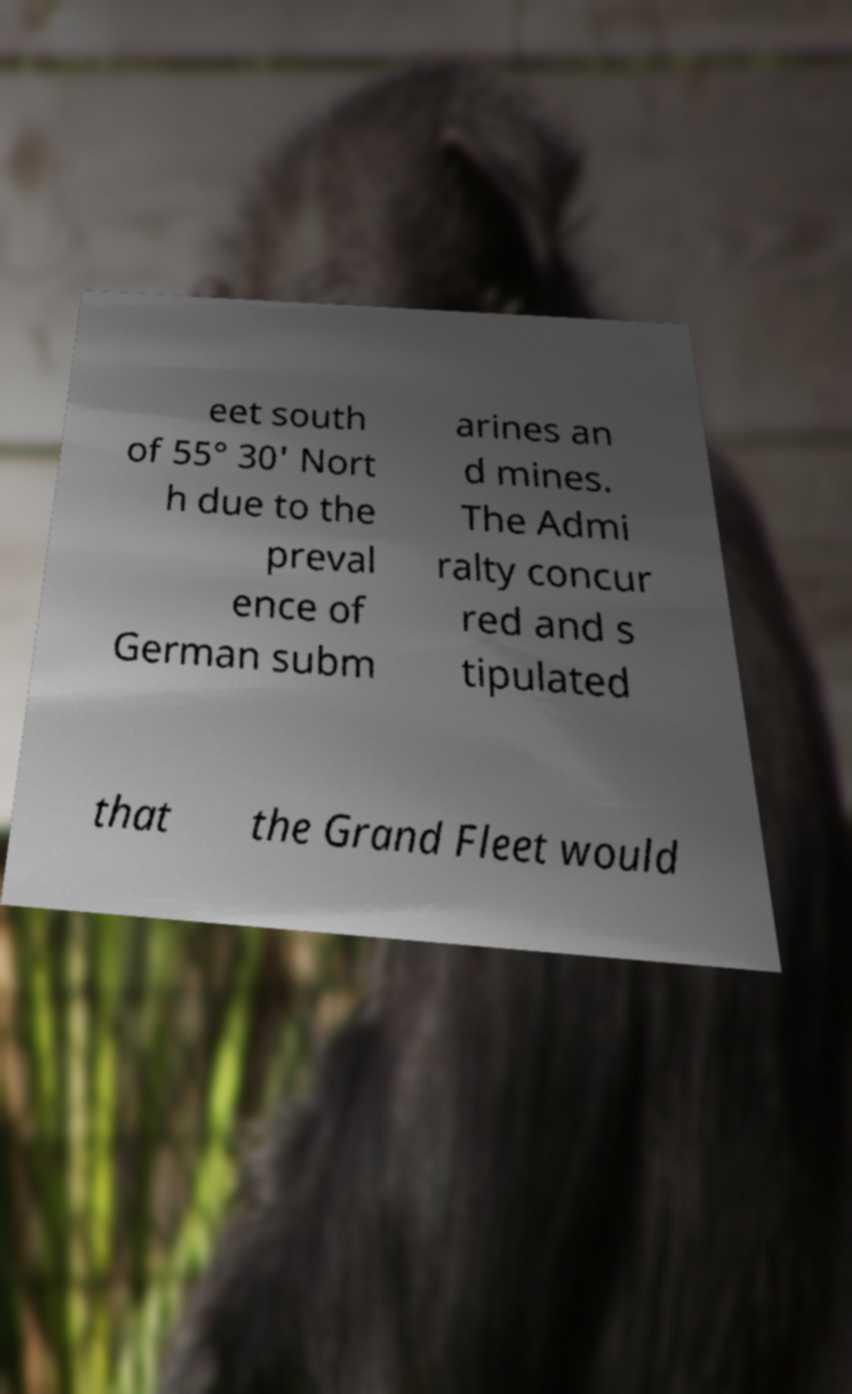There's text embedded in this image that I need extracted. Can you transcribe it verbatim? eet south of 55° 30' Nort h due to the preval ence of German subm arines an d mines. The Admi ralty concur red and s tipulated that the Grand Fleet would 